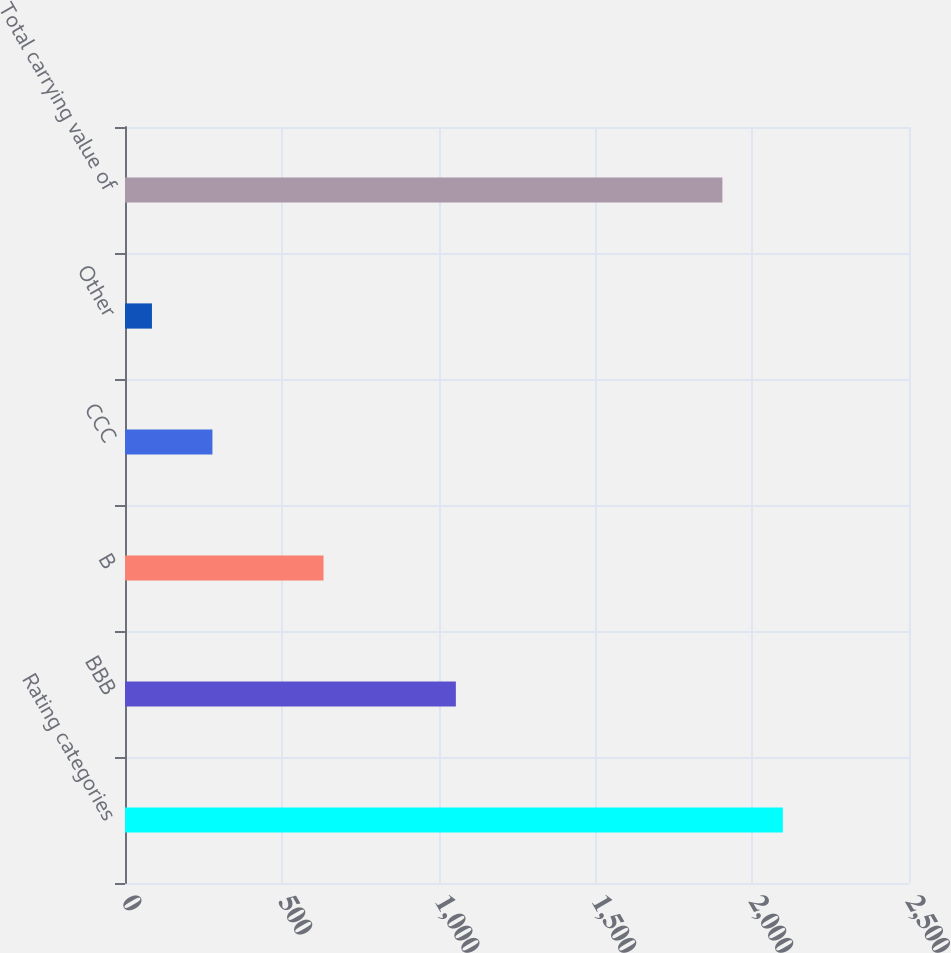Convert chart. <chart><loc_0><loc_0><loc_500><loc_500><bar_chart><fcel>Rating categories<fcel>BBB<fcel>B<fcel>CCC<fcel>Other<fcel>Total carrying value of<nl><fcel>2097.8<fcel>1055<fcel>633<fcel>278.8<fcel>86<fcel>1905<nl></chart> 